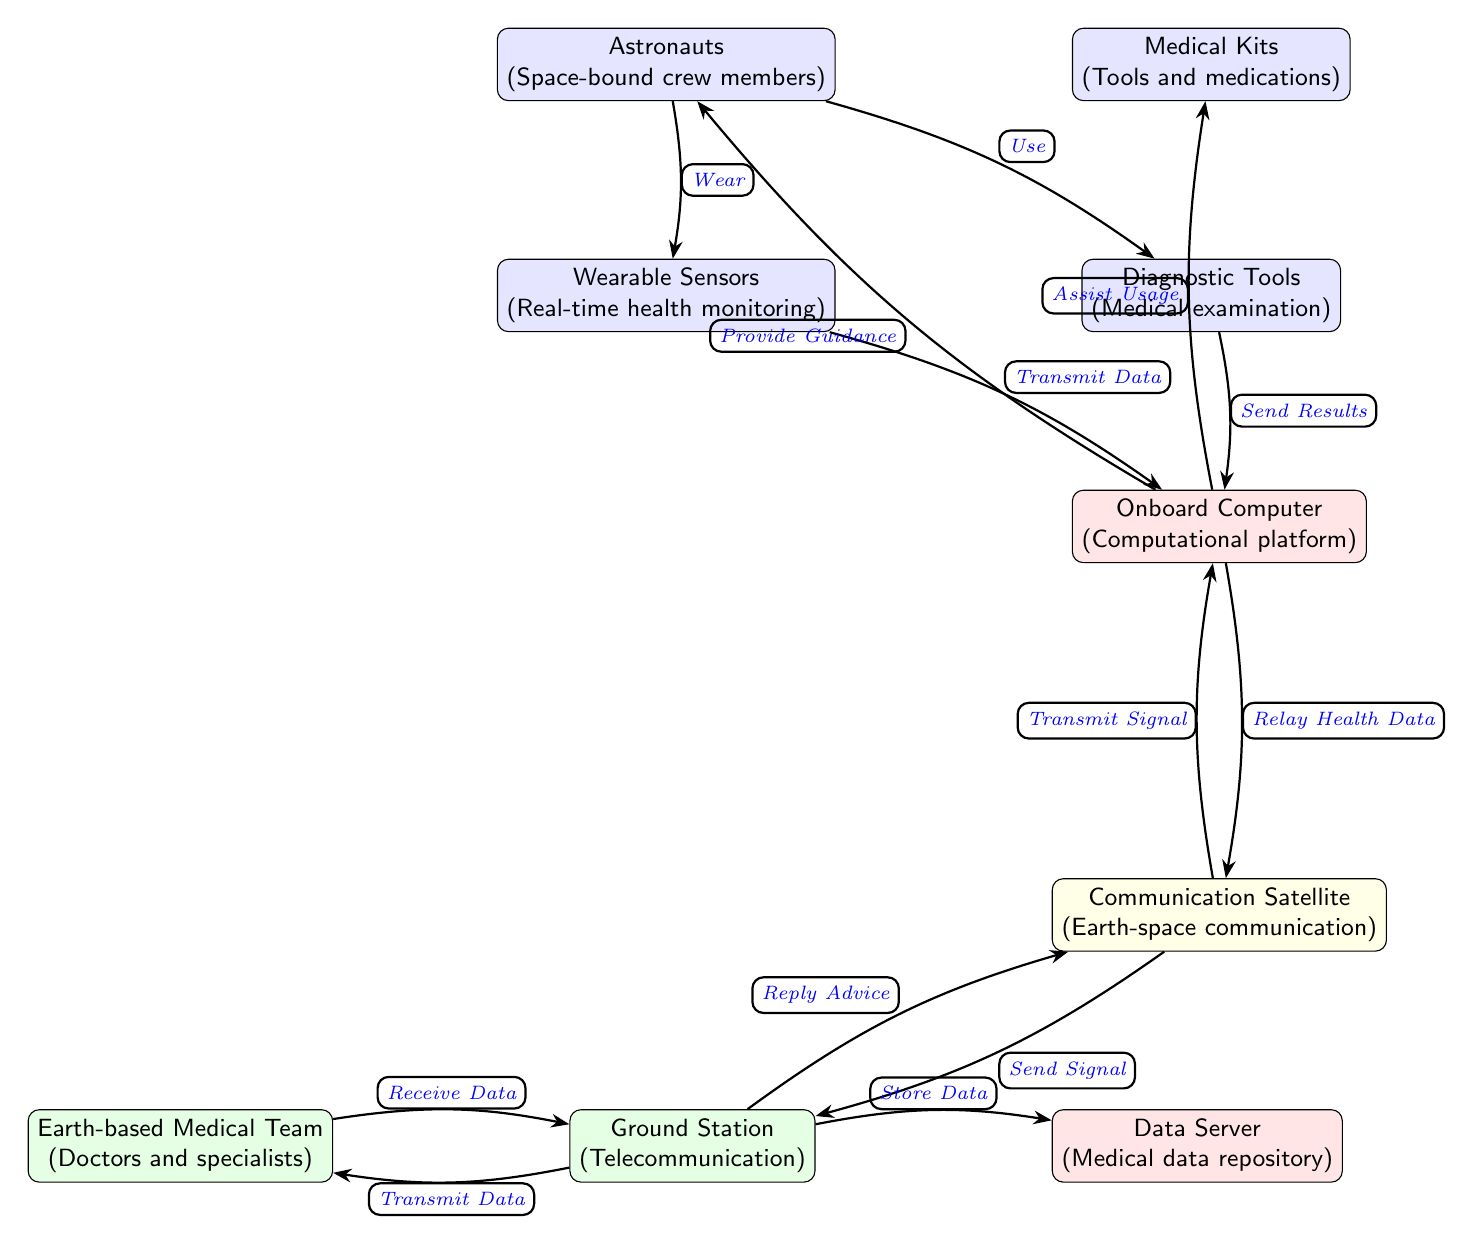What is the role of wearable sensors in the diagram? Wearable sensors are responsible for real-time health monitoring for the astronauts, as indicated in the diagram. They transmit health data to the onboard computer, forming part of the workflow for remote diagnostics.
Answer: Real-time health monitoring How many main nodes are represented in the diagram? The diagram depicts eight main nodes: astronauts, medical kits, wearable sensors, diagnostic tools, onboard computer, communication satellite, ground station, and medical team.
Answer: Eight What is the data flow from astronauts to the medical team? Astronauts wear sensors that transmit data to the onboard computer. The onboard computer relays this health data to the communication satellite, which sends the signal to the ground station. The ground station then transmits this data to the earth-based medical team.
Answer: Astronauts → wearable sensors → onboard computer → communication satellite → ground station → medical team Which node is responsible for providing guidance back to the astronauts? The onboard computer provides guidance to the astronauts by processing the data from the medical team and assisting in diagnostic procedures, as represented in the diagram.
Answer: Onboard computer What is the function of the communication satellite in the workflow? The communication satellite plays a crucial role by sending signals between the onboard computer and the ground station, enabling continuous communication and data transmission throughout the workflow.
Answer: Send signals What type of tools are included in the medical kits? The medical kits include tools and medications that astronauts can use for medical examinations, as indicated in the workflow from the astronauts to the diagnostic tools.
Answer: Tools and medications What is the endpoint for the data transmitted from the ground station? The data from the ground station is transmitted to both the medical team and is also stored in the data server, indicating dual functionality in data management.
Answer: Medical team and data server How does the onboard computer assist astronauts? The onboard computer assists astronauts by providing guidance based on the data collected from the wearable sensors and diagnostic tools, ensuring that they receive informed medical support in space.
Answer: Provide guidance 